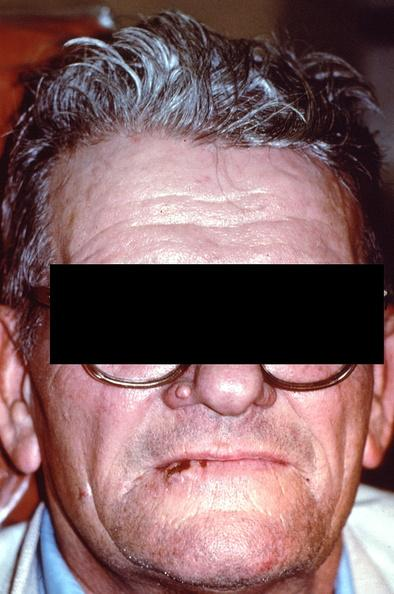does this myoma show squamous cell carcinoma, lip?
Answer the question using a single word or phrase. No 